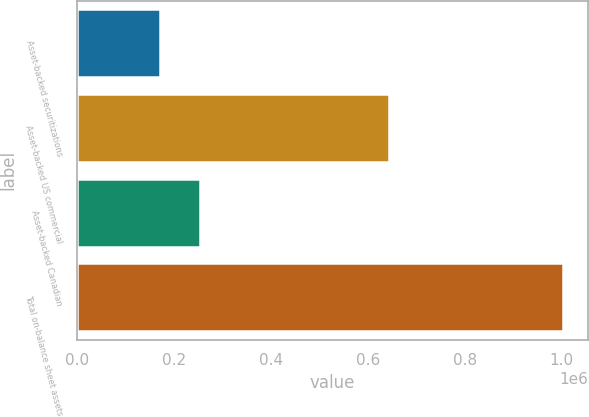<chart> <loc_0><loc_0><loc_500><loc_500><bar_chart><fcel>Asset-backed securitizations<fcel>Asset-backed US commercial<fcel>Asset-backed Canadian<fcel>Total on-balance sheet assets<nl><fcel>171547<fcel>644101<fcel>254734<fcel>1.00341e+06<nl></chart> 